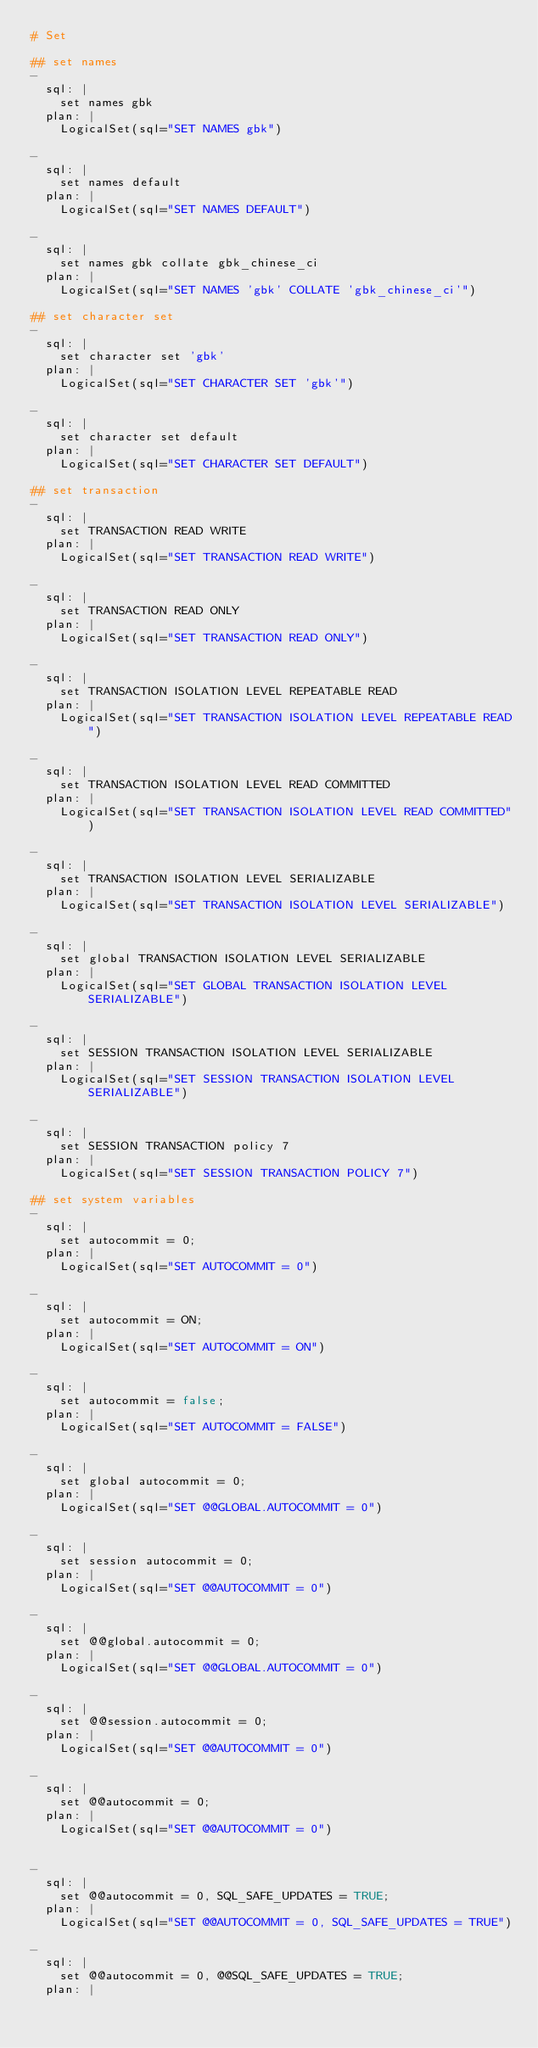Convert code to text. <code><loc_0><loc_0><loc_500><loc_500><_YAML_># Set

## set names
-
  sql: |
    set names gbk
  plan: |
    LogicalSet(sql="SET NAMES gbk")

-
  sql: |
    set names default
  plan: |
    LogicalSet(sql="SET NAMES DEFAULT")

-
  sql: |
    set names gbk collate gbk_chinese_ci
  plan: |
    LogicalSet(sql="SET NAMES 'gbk' COLLATE 'gbk_chinese_ci'")

## set character set
-
  sql: |
    set character set 'gbk'
  plan: |
    LogicalSet(sql="SET CHARACTER SET 'gbk'")

-
  sql: |
    set character set default
  plan: |
    LogicalSet(sql="SET CHARACTER SET DEFAULT")

## set transaction
-
  sql: |
    set TRANSACTION READ WRITE
  plan: |
    LogicalSet(sql="SET TRANSACTION READ WRITE")

-
  sql: |
    set TRANSACTION READ ONLY
  plan: |
    LogicalSet(sql="SET TRANSACTION READ ONLY")

-
  sql: |
    set TRANSACTION ISOLATION LEVEL REPEATABLE READ
  plan: |
    LogicalSet(sql="SET TRANSACTION ISOLATION LEVEL REPEATABLE READ")

-
  sql: |
    set TRANSACTION ISOLATION LEVEL READ COMMITTED
  plan: |
    LogicalSet(sql="SET TRANSACTION ISOLATION LEVEL READ COMMITTED")

-
  sql: |
    set TRANSACTION ISOLATION LEVEL SERIALIZABLE
  plan: |
    LogicalSet(sql="SET TRANSACTION ISOLATION LEVEL SERIALIZABLE")

-
  sql: |
    set global TRANSACTION ISOLATION LEVEL SERIALIZABLE
  plan: |
    LogicalSet(sql="SET GLOBAL TRANSACTION ISOLATION LEVEL SERIALIZABLE")

-
  sql: |
    set SESSION TRANSACTION ISOLATION LEVEL SERIALIZABLE
  plan: |
    LogicalSet(sql="SET SESSION TRANSACTION ISOLATION LEVEL SERIALIZABLE")

-
  sql: |
    set SESSION TRANSACTION policy 7
  plan: |
    LogicalSet(sql="SET SESSION TRANSACTION POLICY 7")

## set system variables
-
  sql: |
    set autocommit = 0;
  plan: |
    LogicalSet(sql="SET AUTOCOMMIT = 0")

-
  sql: |
    set autocommit = ON;
  plan: |
    LogicalSet(sql="SET AUTOCOMMIT = ON")

-
  sql: |
    set autocommit = false;
  plan: |
    LogicalSet(sql="SET AUTOCOMMIT = FALSE")

-
  sql: |
    set global autocommit = 0;
  plan: |
    LogicalSet(sql="SET @@GLOBAL.AUTOCOMMIT = 0")

-
  sql: |
    set session autocommit = 0;
  plan: |
    LogicalSet(sql="SET @@AUTOCOMMIT = 0")

-
  sql: |
    set @@global.autocommit = 0;
  plan: |
    LogicalSet(sql="SET @@GLOBAL.AUTOCOMMIT = 0")

-
  sql: |
    set @@session.autocommit = 0;
  plan: |
    LogicalSet(sql="SET @@AUTOCOMMIT = 0")

-
  sql: |
    set @@autocommit = 0;
  plan: |
    LogicalSet(sql="SET @@AUTOCOMMIT = 0")


-
  sql: |
    set @@autocommit = 0, SQL_SAFE_UPDATES = TRUE;
  plan: |
    LogicalSet(sql="SET @@AUTOCOMMIT = 0, SQL_SAFE_UPDATES = TRUE")

-
  sql: |
    set @@autocommit = 0, @@SQL_SAFE_UPDATES = TRUE;
  plan: |</code> 